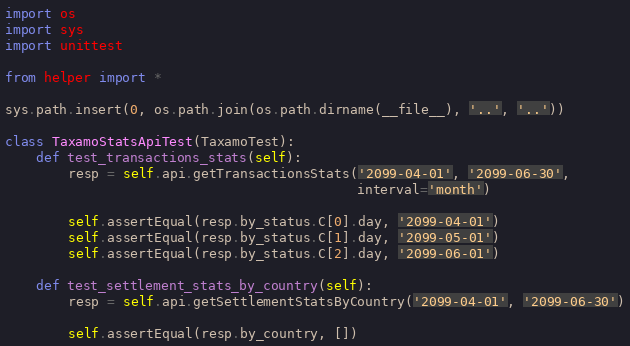<code> <loc_0><loc_0><loc_500><loc_500><_Python_>import os
import sys
import unittest

from helper import *

sys.path.insert(0, os.path.join(os.path.dirname(__file__), '..', '..'))

class TaxamoStatsApiTest(TaxamoTest):
    def test_transactions_stats(self):
        resp = self.api.getTransactionsStats('2099-04-01', '2099-06-30',
                                             interval='month')

        self.assertEqual(resp.by_status.C[0].day, '2099-04-01')
        self.assertEqual(resp.by_status.C[1].day, '2099-05-01')
        self.assertEqual(resp.by_status.C[2].day, '2099-06-01')

    def test_settlement_stats_by_country(self):
        resp = self.api.getSettlementStatsByCountry('2099-04-01', '2099-06-30')

        self.assertEqual(resp.by_country, [])</code> 